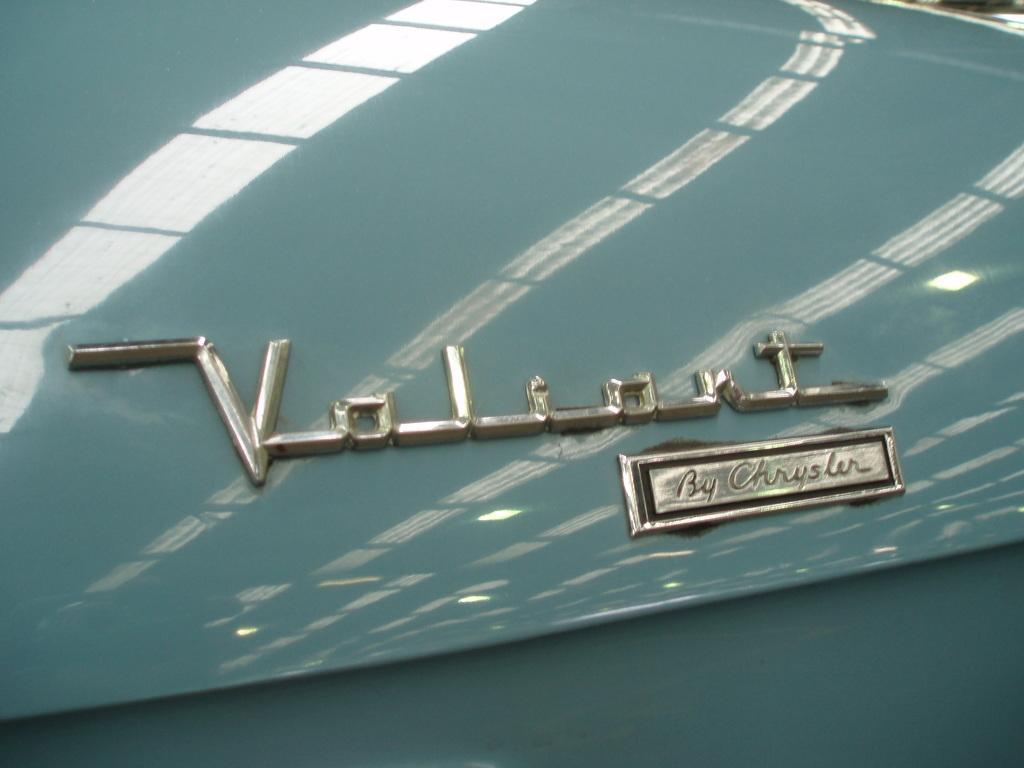In one or two sentences, can you explain what this image depicts? In this image we can see a metal, we can see some text and reflection on it. 